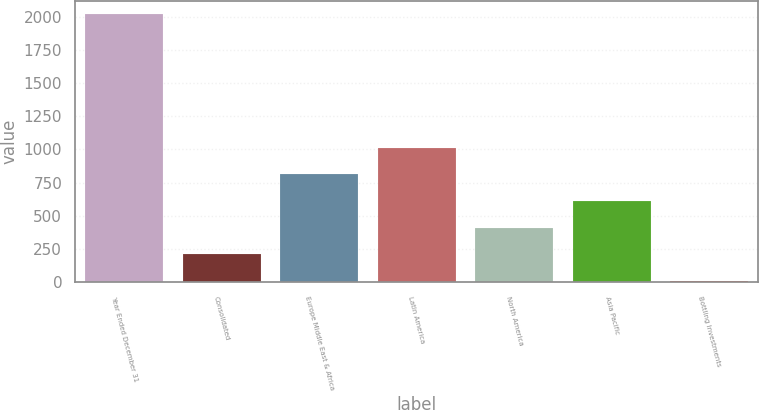Convert chart. <chart><loc_0><loc_0><loc_500><loc_500><bar_chart><fcel>Year Ended December 31<fcel>Consolidated<fcel>Europe Middle East & Africa<fcel>Latin America<fcel>North America<fcel>Asia Pacific<fcel>Bottling Investments<nl><fcel>2017<fcel>210.07<fcel>812.38<fcel>1013.15<fcel>410.84<fcel>611.61<fcel>9.3<nl></chart> 